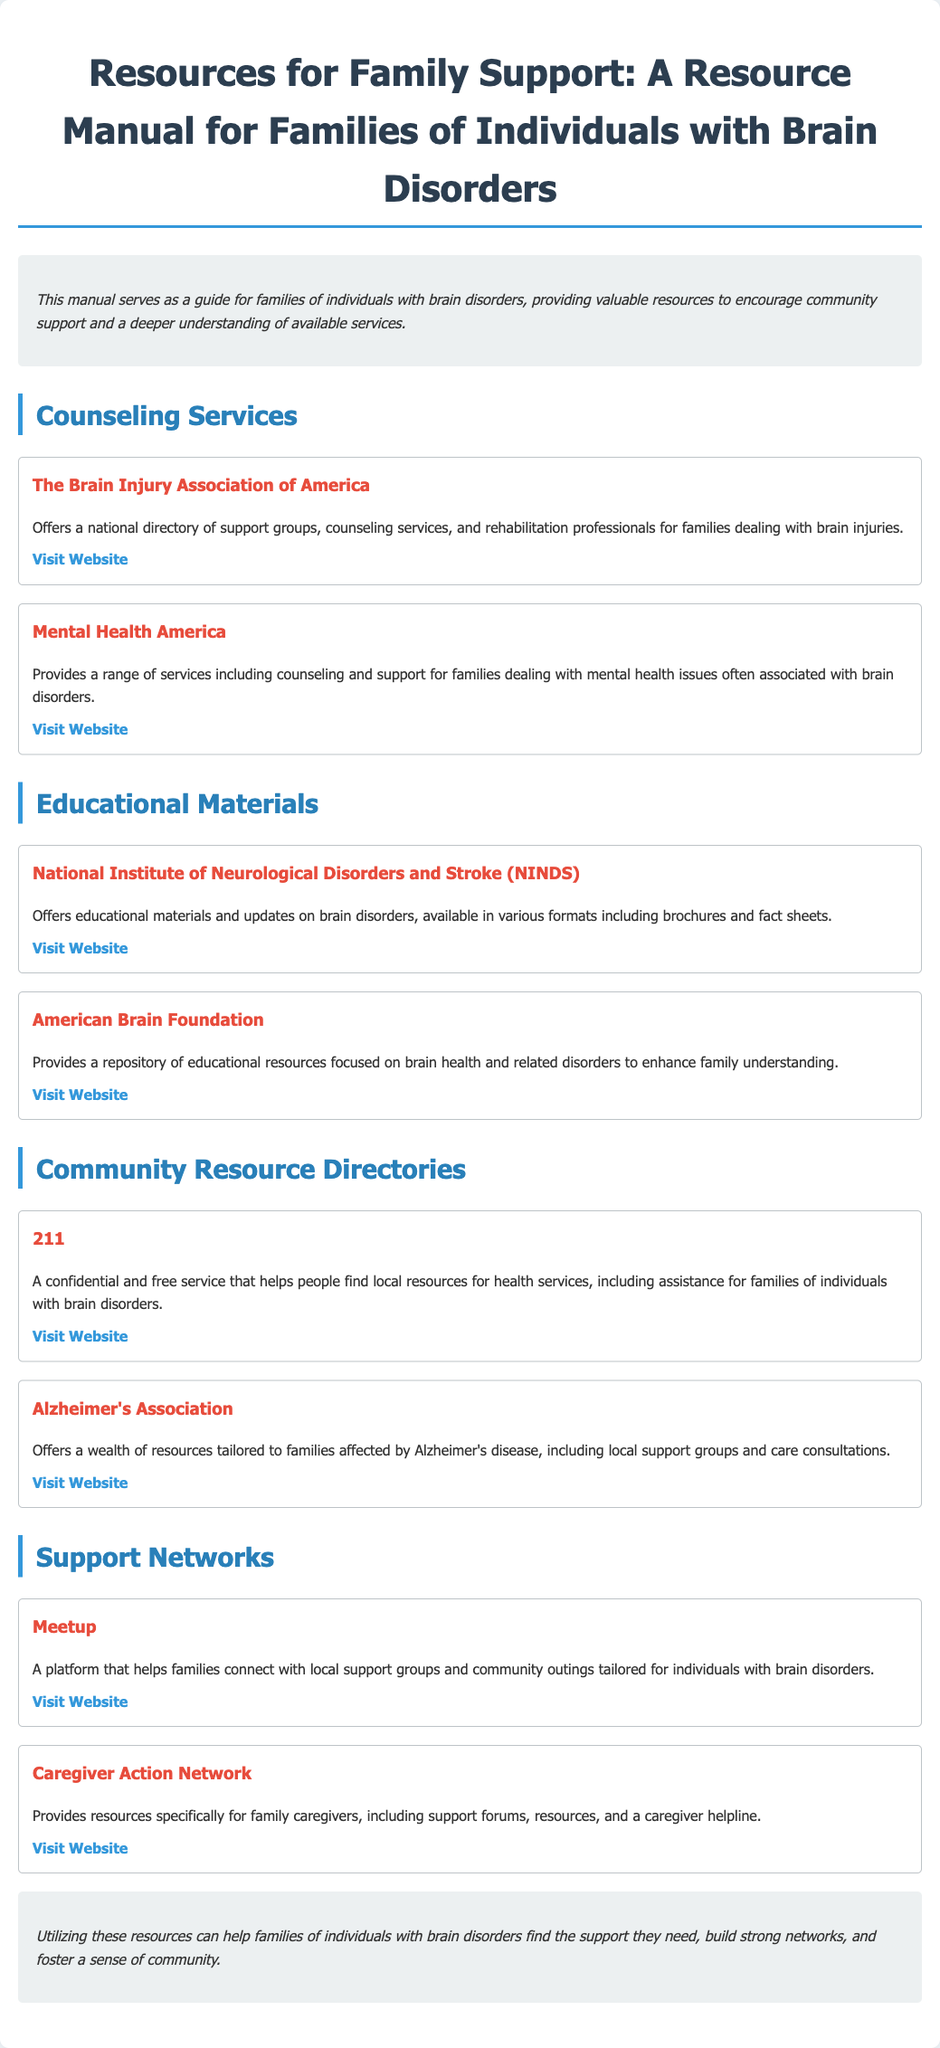What is the title of the manual? The title of the manual is clearly mentioned at the beginning of the document.
Answer: Resources for Family Support: A Resource Manual for Families of Individuals with Brain Disorders How many counseling services are listed? The number of counseling services can be counted from the Counseling Services section.
Answer: 2 What organization provides a national directory of support groups? The specific organization that offers a national directory is mentioned under Counseling Services.
Answer: The Brain Injury Association of America What type of materials does the National Institute of Neurological Disorders and Stroke provide? The type of materials provided is specified in the Educational Materials section.
Answer: Educational materials What resource offers a wealth of support for families affected by Alzheimer's disease? This resource is noted under the Community Resource Directories section.
Answer: Alzheimer's Association What platform helps families connect with local support groups? The document specifies a platform that facilitates connections among families in the Support Networks section.
Answer: Meetup What is the purpose of the Caregiver Action Network? The purpose is provided in the description of the resource under Support Networks.
Answer: Resources specifically for family caregivers Which organization provides overall support and updates on brain disorders? This organization is specified under Educational Materials.
Answer: American Brain Foundation 